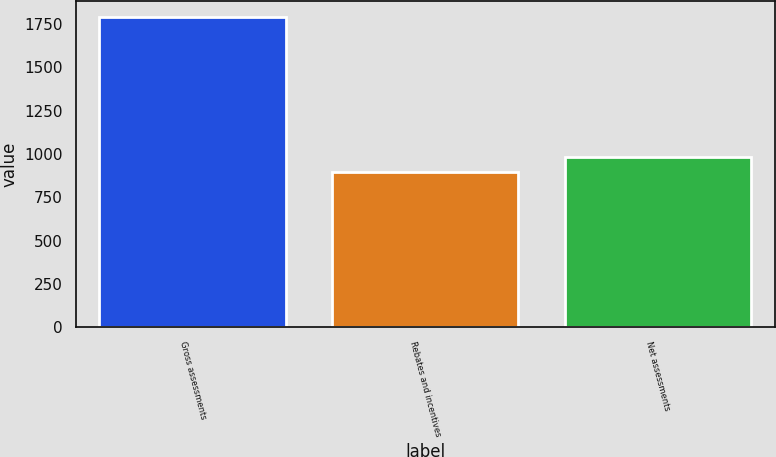<chart> <loc_0><loc_0><loc_500><loc_500><bar_chart><fcel>Gross assessments<fcel>Rebates and incentives<fcel>Net assessments<nl><fcel>1790<fcel>894<fcel>983.6<nl></chart> 